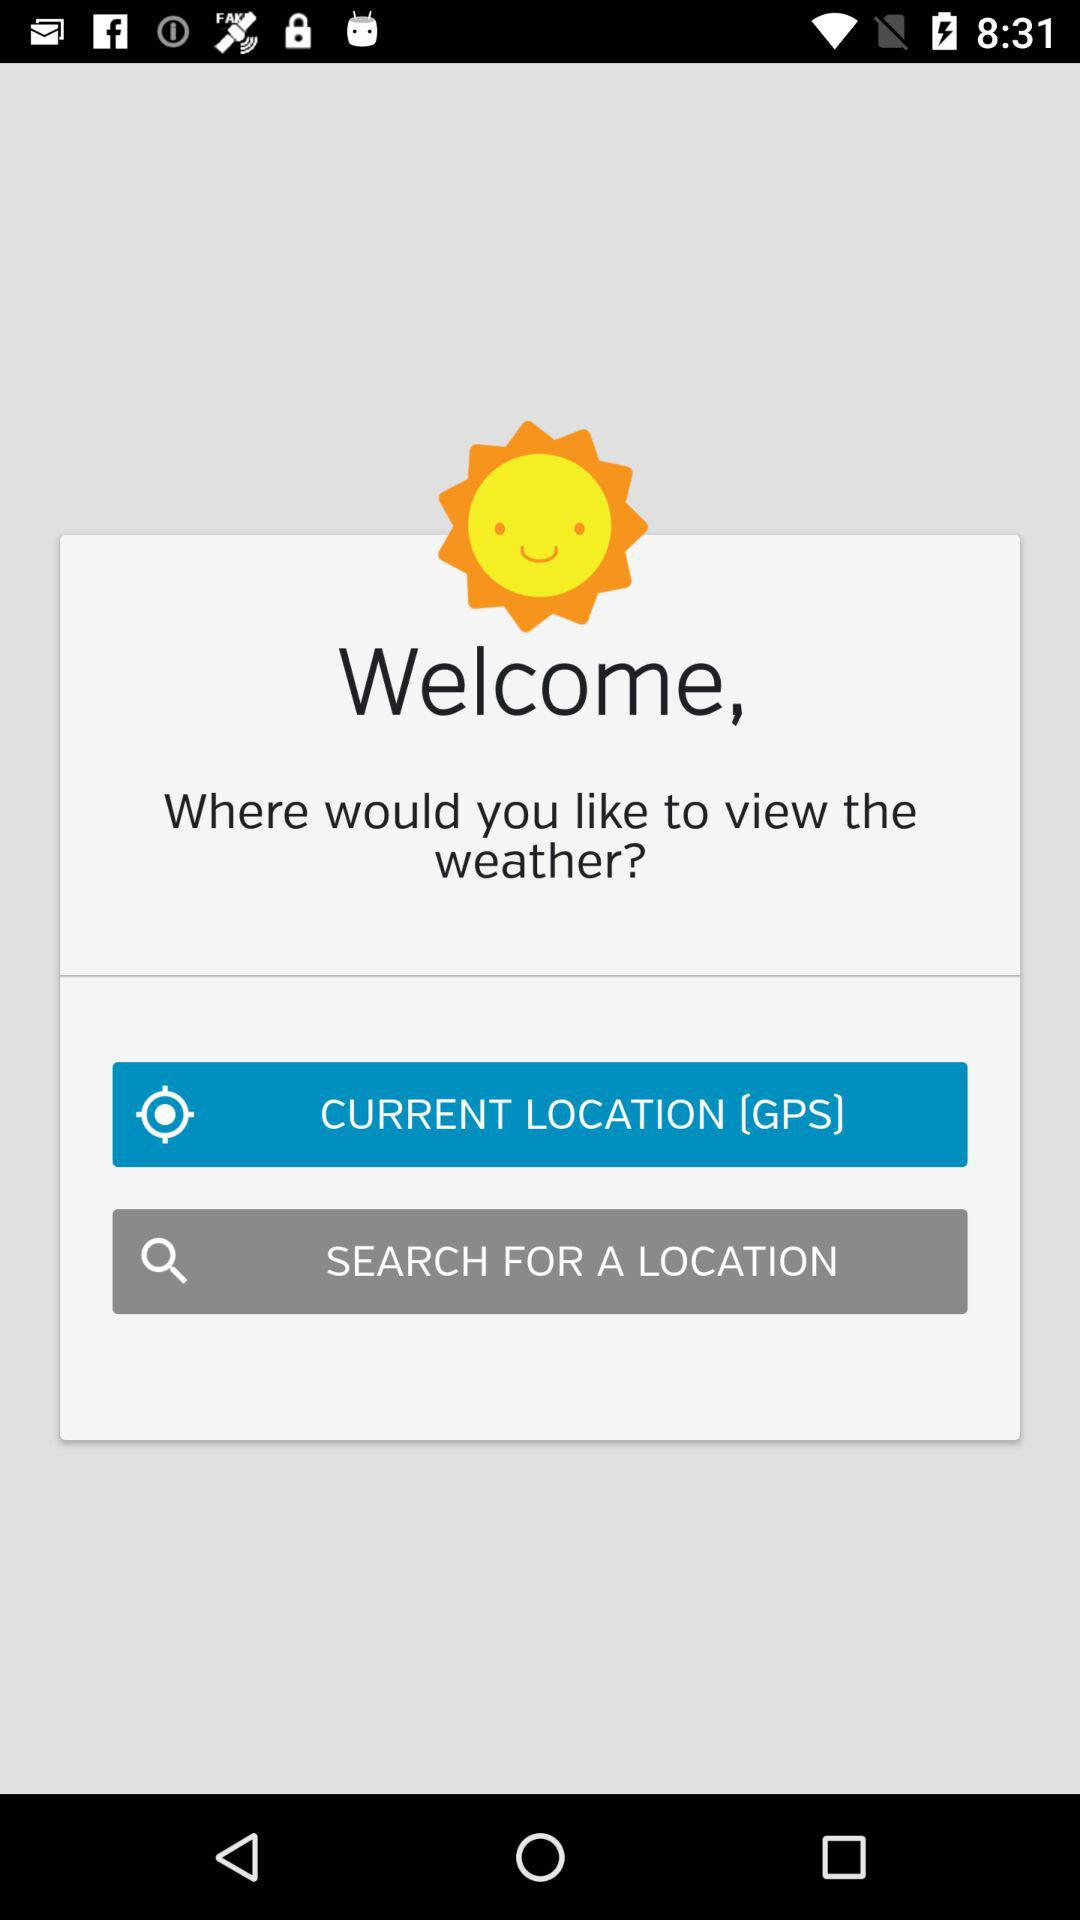What are the available options? The available options are "CURRENT LOCATION (GPS)" and "SEARCH FOR A LOCATION". 